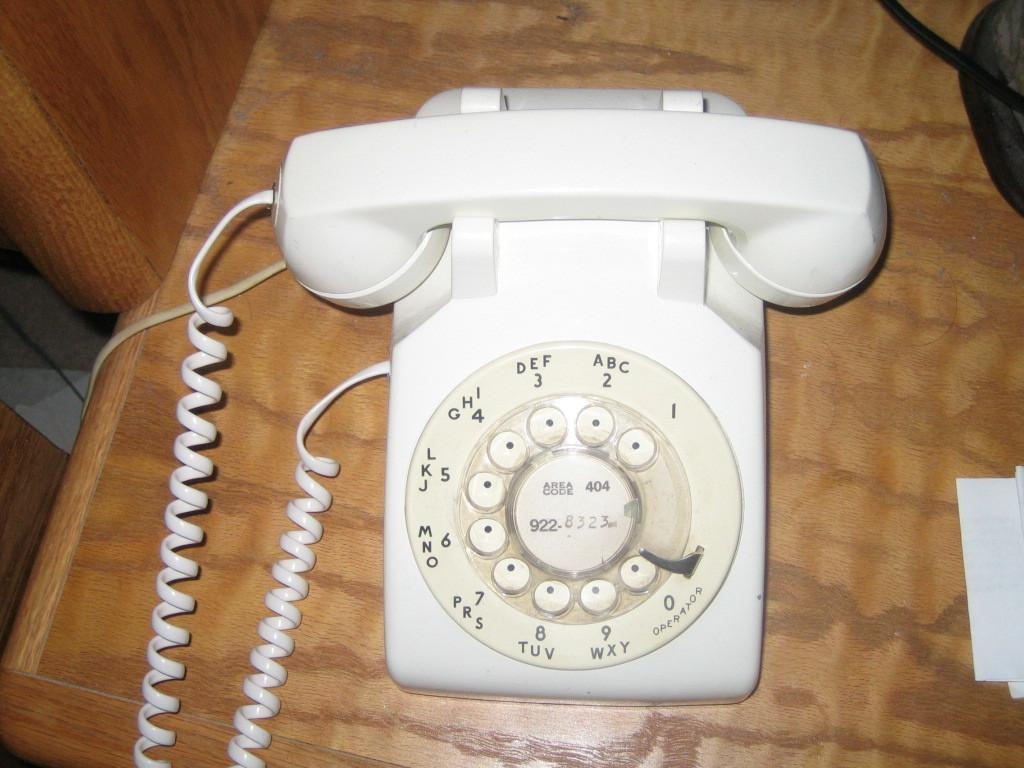What object is placed on the wooden table in the image? There is a telephone on a wooden table in the image. What else can be seen in the image besides the telephone? Papers are visible in the image. Can you describe the unspecified object on the right side of the image? Unfortunately, the provided facts do not give enough information to describe the unspecified object on the right side of the image. Is the person teaching a class while driving a donkey in the image? There is no person, class, or donkey present in the image, so this scenario cannot be observed. 